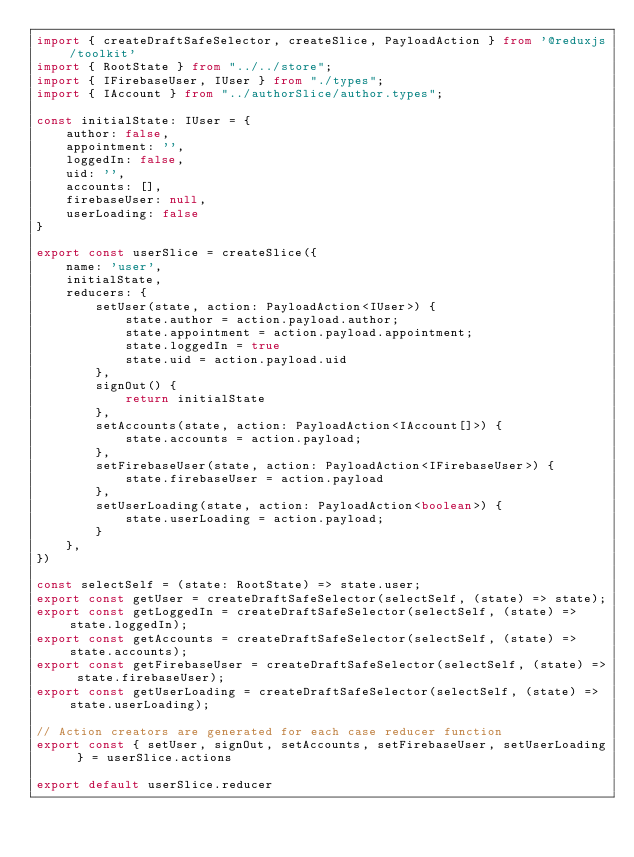<code> <loc_0><loc_0><loc_500><loc_500><_TypeScript_>import { createDraftSafeSelector, createSlice, PayloadAction } from '@reduxjs/toolkit'
import { RootState } from "../../store";
import { IFirebaseUser, IUser } from "./types";
import { IAccount } from "../authorSlice/author.types";

const initialState: IUser = {
    author: false,
    appointment: '',
    loggedIn: false,
    uid: '',
    accounts: [],
    firebaseUser: null,
    userLoading: false
}

export const userSlice = createSlice({
    name: 'user',
    initialState,
    reducers: {
        setUser(state, action: PayloadAction<IUser>) {
            state.author = action.payload.author;
            state.appointment = action.payload.appointment;
            state.loggedIn = true
            state.uid = action.payload.uid
        },
        signOut() {
            return initialState
        },
        setAccounts(state, action: PayloadAction<IAccount[]>) {
            state.accounts = action.payload;
        },
        setFirebaseUser(state, action: PayloadAction<IFirebaseUser>) {
            state.firebaseUser = action.payload
        },
        setUserLoading(state, action: PayloadAction<boolean>) {
            state.userLoading = action.payload;
        }
    },
})

const selectSelf = (state: RootState) => state.user;
export const getUser = createDraftSafeSelector(selectSelf, (state) => state);
export const getLoggedIn = createDraftSafeSelector(selectSelf, (state) => state.loggedIn);
export const getAccounts = createDraftSafeSelector(selectSelf, (state) => state.accounts);
export const getFirebaseUser = createDraftSafeSelector(selectSelf, (state) => state.firebaseUser);
export const getUserLoading = createDraftSafeSelector(selectSelf, (state) => state.userLoading);

// Action creators are generated for each case reducer function
export const { setUser, signOut, setAccounts, setFirebaseUser, setUserLoading } = userSlice.actions

export default userSlice.reducer</code> 